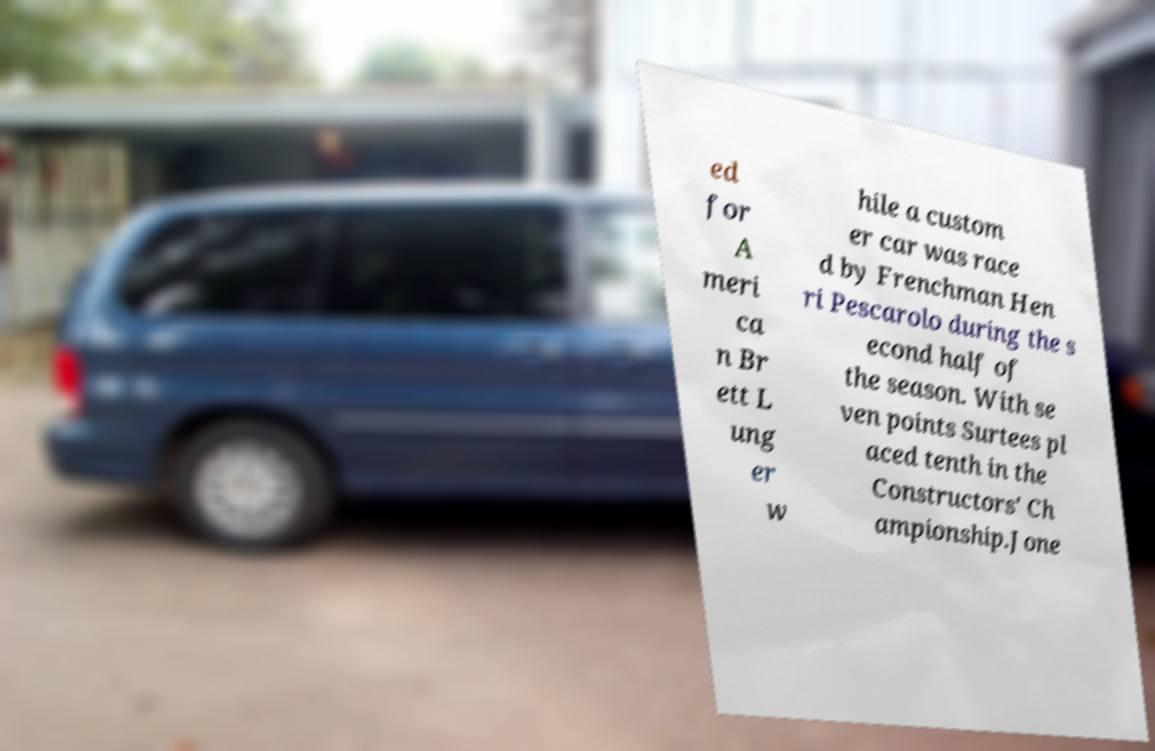Could you extract and type out the text from this image? ed for A meri ca n Br ett L ung er w hile a custom er car was race d by Frenchman Hen ri Pescarolo during the s econd half of the season. With se ven points Surtees pl aced tenth in the Constructors' Ch ampionship.Jone 